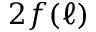Convert formula to latex. <formula><loc_0><loc_0><loc_500><loc_500>2 f ( \ell )</formula> 